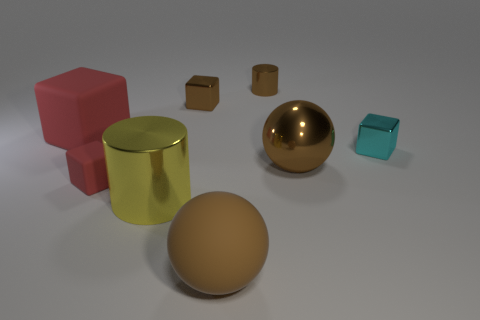How many other brown metal blocks are the same size as the brown metallic block?
Ensure brevity in your answer.  0. How many metal cylinders are to the left of the brown rubber object to the left of the large brown shiny thing?
Give a very brief answer. 1. Is the color of the metallic block that is behind the small cyan metal thing the same as the large rubber sphere?
Offer a very short reply. Yes. Is there a matte block in front of the big cube in front of the shiny cylinder that is behind the large metal sphere?
Offer a very short reply. Yes. The small object that is both in front of the small brown metallic cube and to the right of the large cylinder has what shape?
Offer a terse response. Cube. Are there any large objects of the same color as the matte sphere?
Provide a short and direct response. Yes. What color is the tiny thing that is on the right side of the big brown thing that is behind the brown matte ball?
Give a very brief answer. Cyan. What is the size of the cylinder behind the red cube that is in front of the big brown object behind the yellow thing?
Offer a terse response. Small. Does the big cylinder have the same material as the red thing to the right of the big block?
Offer a terse response. No. What size is the red block that is made of the same material as the big red object?
Keep it short and to the point. Small. 